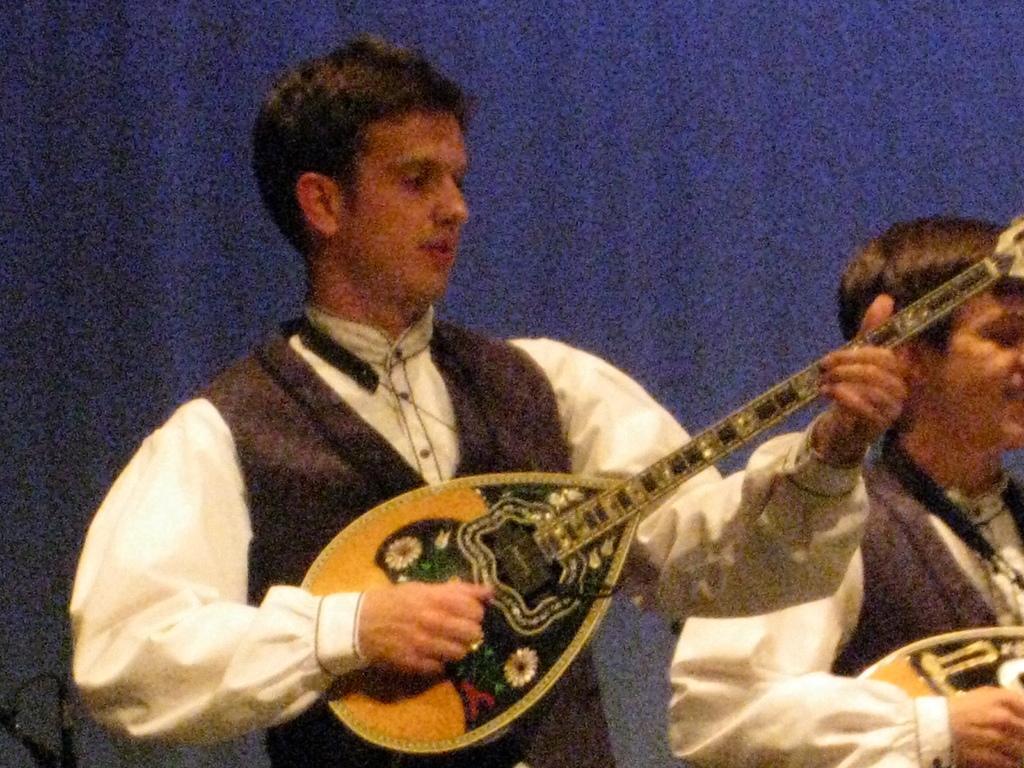Could you give a brief overview of what you see in this image? A man is playing a musical instrument with his hands. There another man beside him. There is a blue screen behind these. 